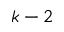Convert formula to latex. <formula><loc_0><loc_0><loc_500><loc_500>k - 2</formula> 